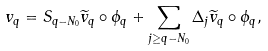Convert formula to latex. <formula><loc_0><loc_0><loc_500><loc_500>v _ { q } = S _ { q - N _ { 0 } } \widetilde { v } _ { q } \circ \phi _ { q } + \sum _ { j \geq q - N _ { 0 } } \Delta _ { j } \widetilde { v } _ { q } \circ \phi _ { q } ,</formula> 